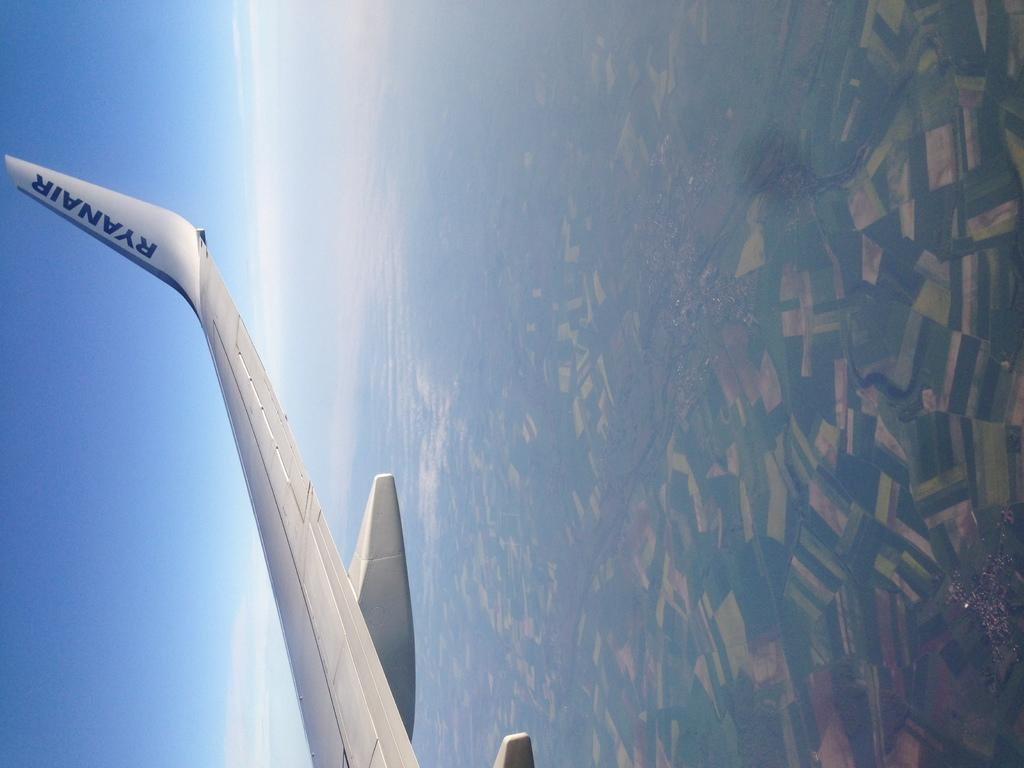<image>
Create a compact narrative representing the image presented. The tail wing of a plane that says RyanAir. 